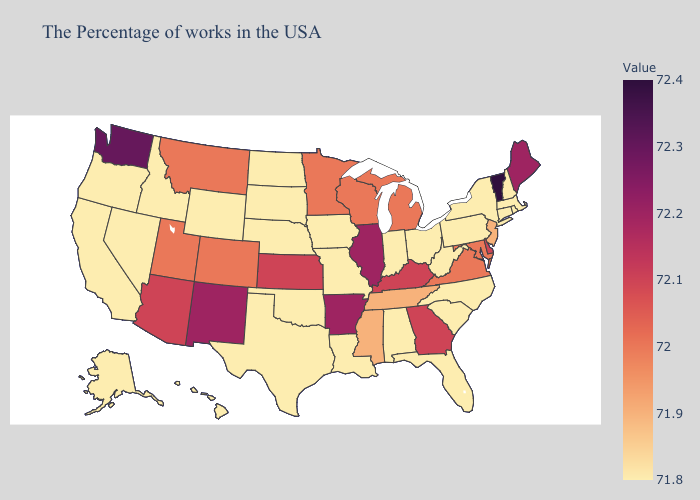Does Vermont have the highest value in the Northeast?
Answer briefly. Yes. Does Pennsylvania have the highest value in the USA?
Concise answer only. No. Among the states that border Georgia , does Tennessee have the highest value?
Quick response, please. Yes. Among the states that border Tennessee , does Arkansas have the highest value?
Write a very short answer. Yes. Which states hav the highest value in the West?
Concise answer only. Washington. 